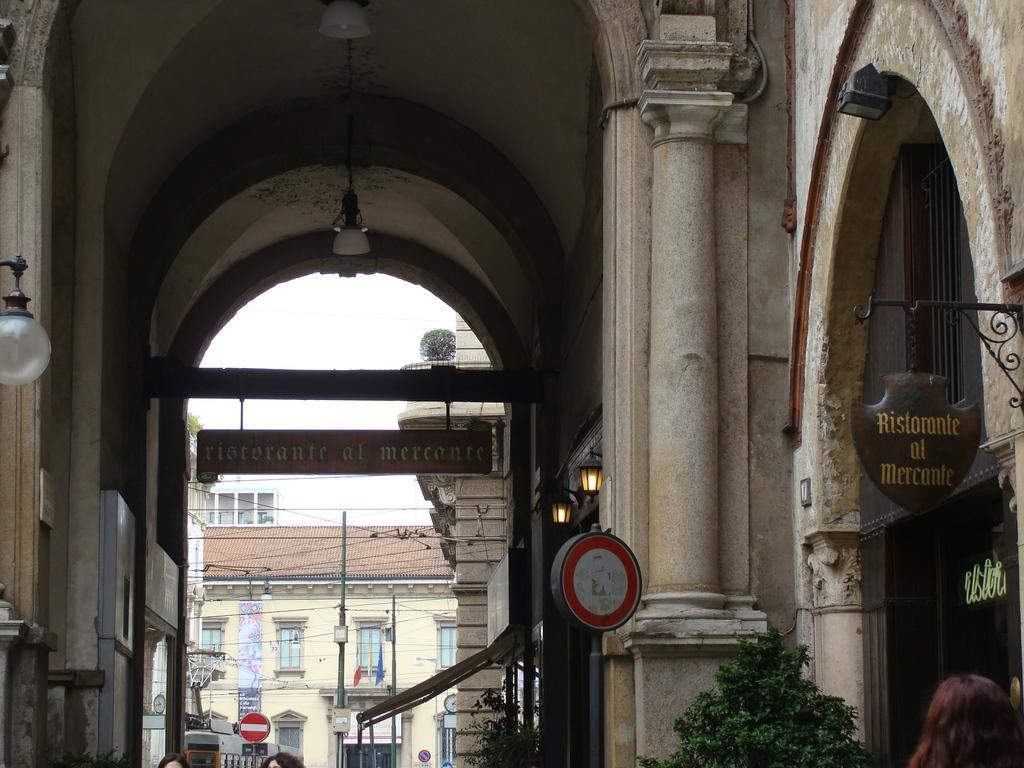Please provide a concise description of this image. In this image in the foreground there are buildings and boards, on the boards there is text and some lights, trees and in the background there are some houses, poles, boards, windows. And at the top there is ceiling and some lights. 